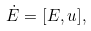<formula> <loc_0><loc_0><loc_500><loc_500>\dot { E } = [ E , u ] ,</formula> 